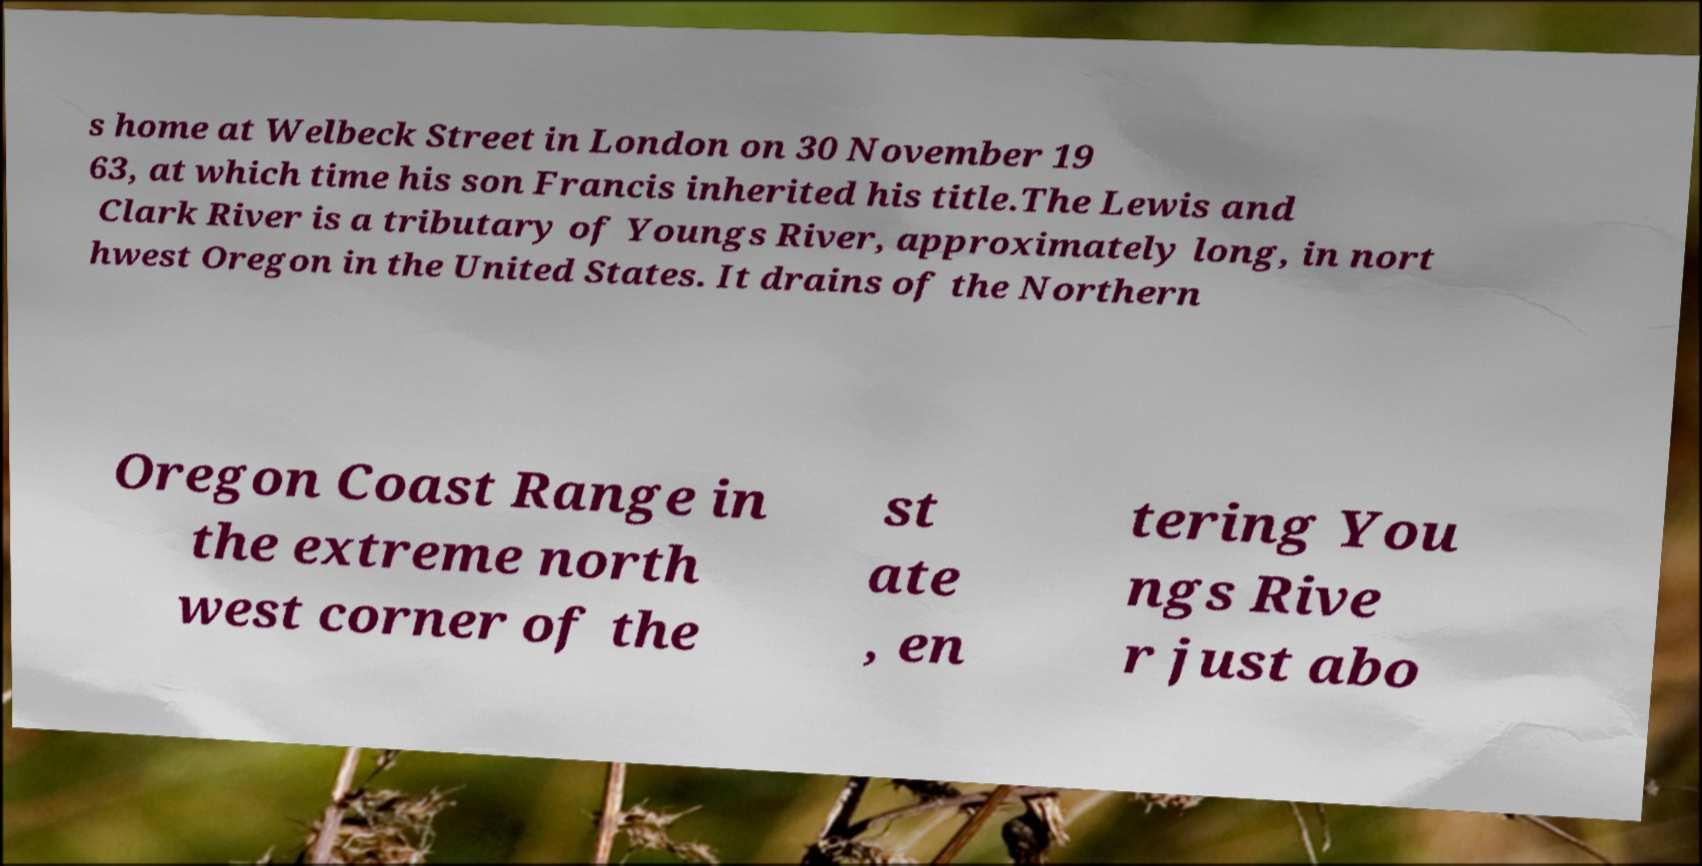Please identify and transcribe the text found in this image. s home at Welbeck Street in London on 30 November 19 63, at which time his son Francis inherited his title.The Lewis and Clark River is a tributary of Youngs River, approximately long, in nort hwest Oregon in the United States. It drains of the Northern Oregon Coast Range in the extreme north west corner of the st ate , en tering You ngs Rive r just abo 